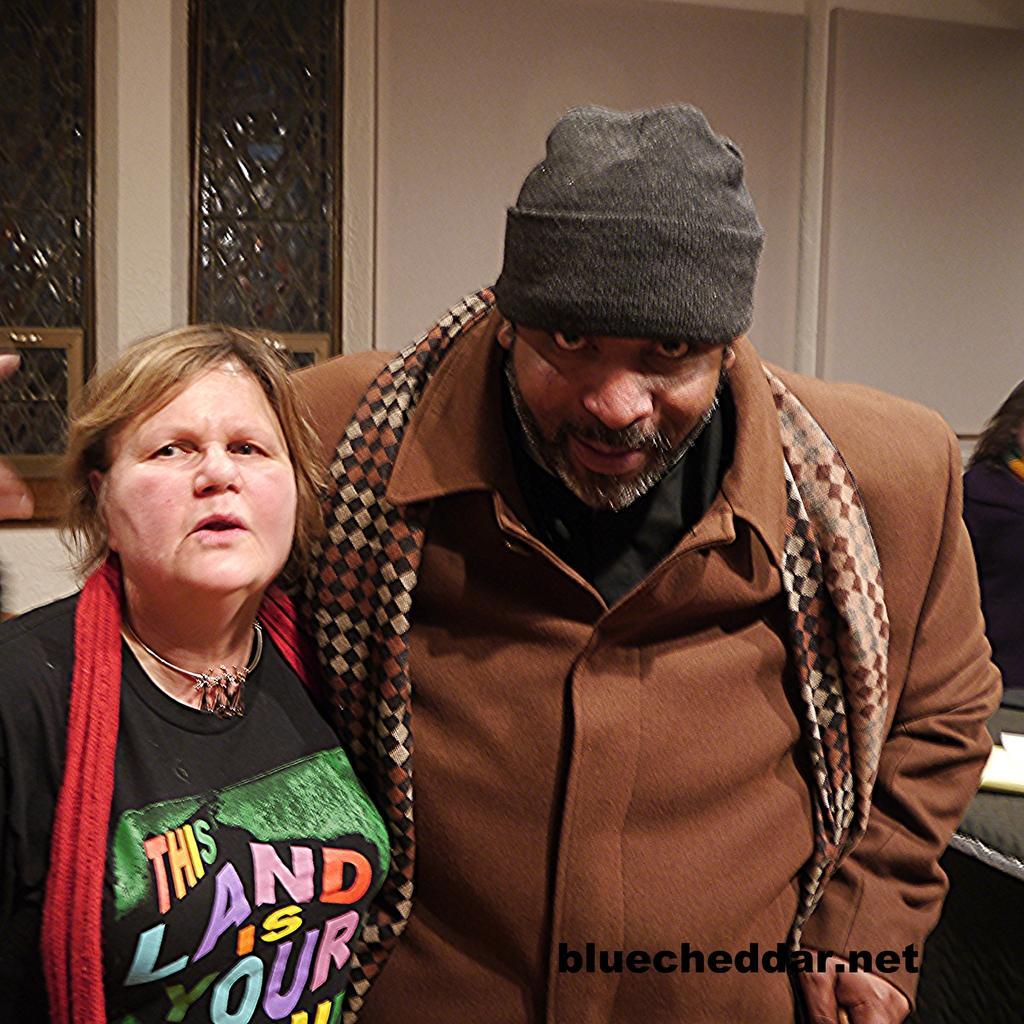How would you summarize this image in a sentence or two? In the foreground of the picture we can see a woman and a man standing. In the background there are windows, wall, person and other objects. 